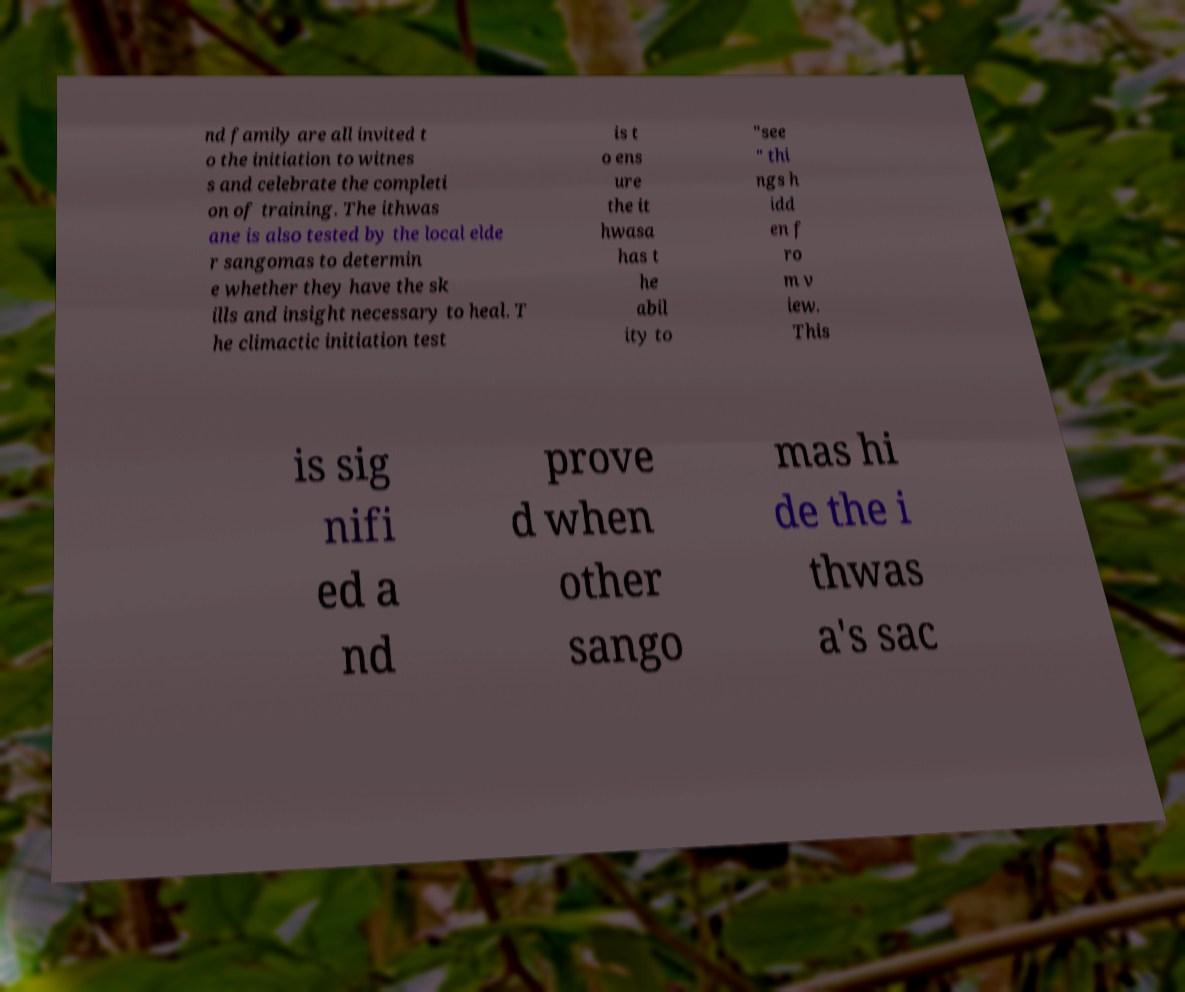Could you assist in decoding the text presented in this image and type it out clearly? nd family are all invited t o the initiation to witnes s and celebrate the completi on of training. The ithwas ane is also tested by the local elde r sangomas to determin e whether they have the sk ills and insight necessary to heal. T he climactic initiation test is t o ens ure the it hwasa has t he abil ity to "see " thi ngs h idd en f ro m v iew. This is sig nifi ed a nd prove d when other sango mas hi de the i thwas a's sac 